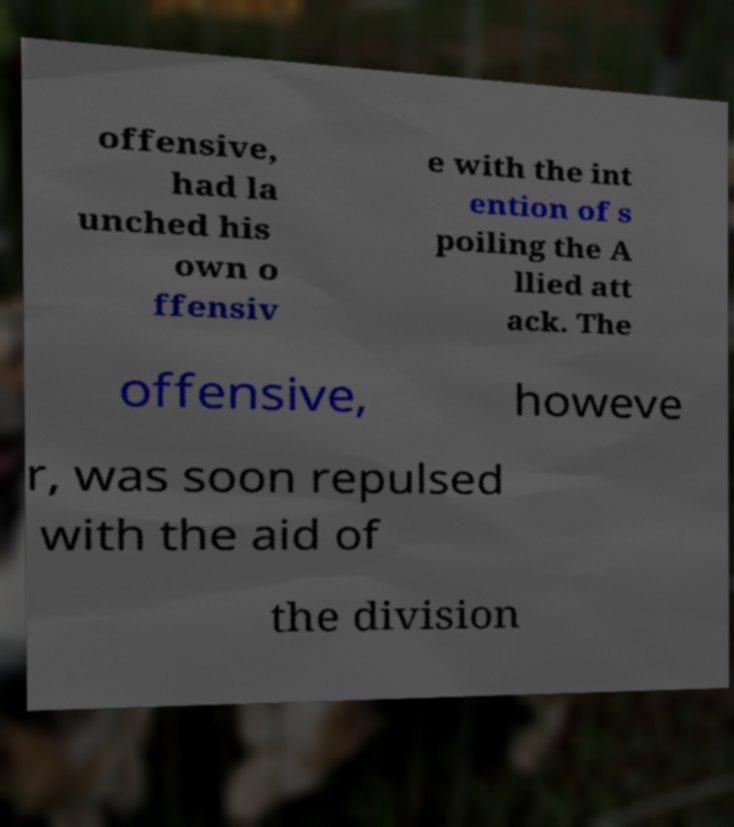Can you read and provide the text displayed in the image?This photo seems to have some interesting text. Can you extract and type it out for me? offensive, had la unched his own o ffensiv e with the int ention of s poiling the A llied att ack. The offensive, howeve r, was soon repulsed with the aid of the division 